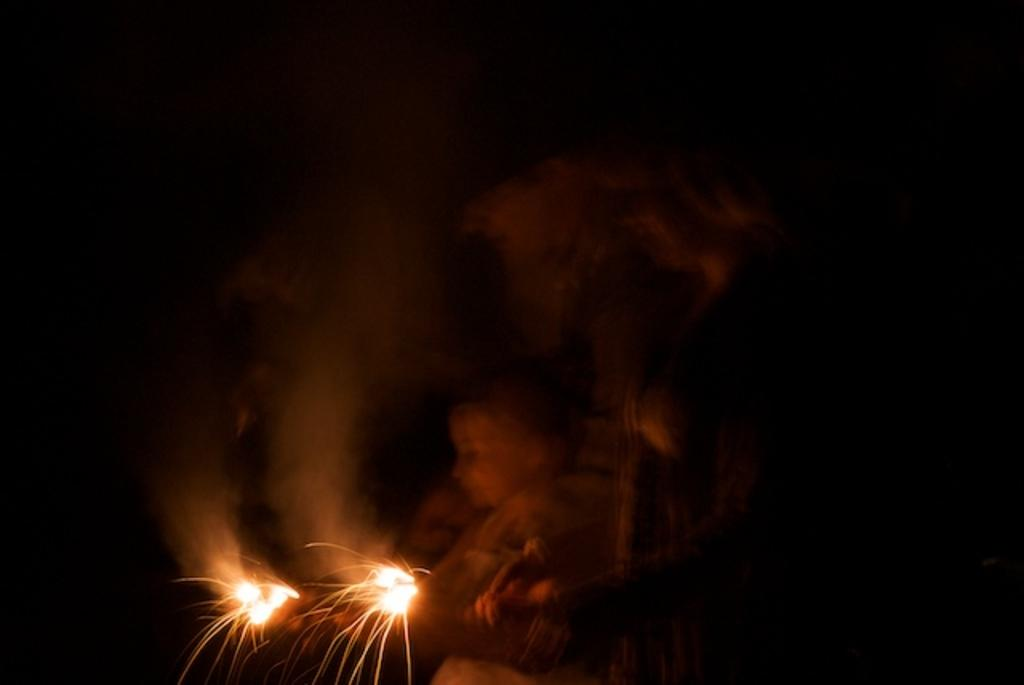How many people are present in the image? There are three people in the image. What are the people doing in the image? The people are lighting crackers. What can be observed about the background of the image? The background of the image is black. How does the addition of a grandfather change the dynamics of the image? There is no mention of a grandfather in the image, so it is not possible to determine how his addition would change the dynamics. 